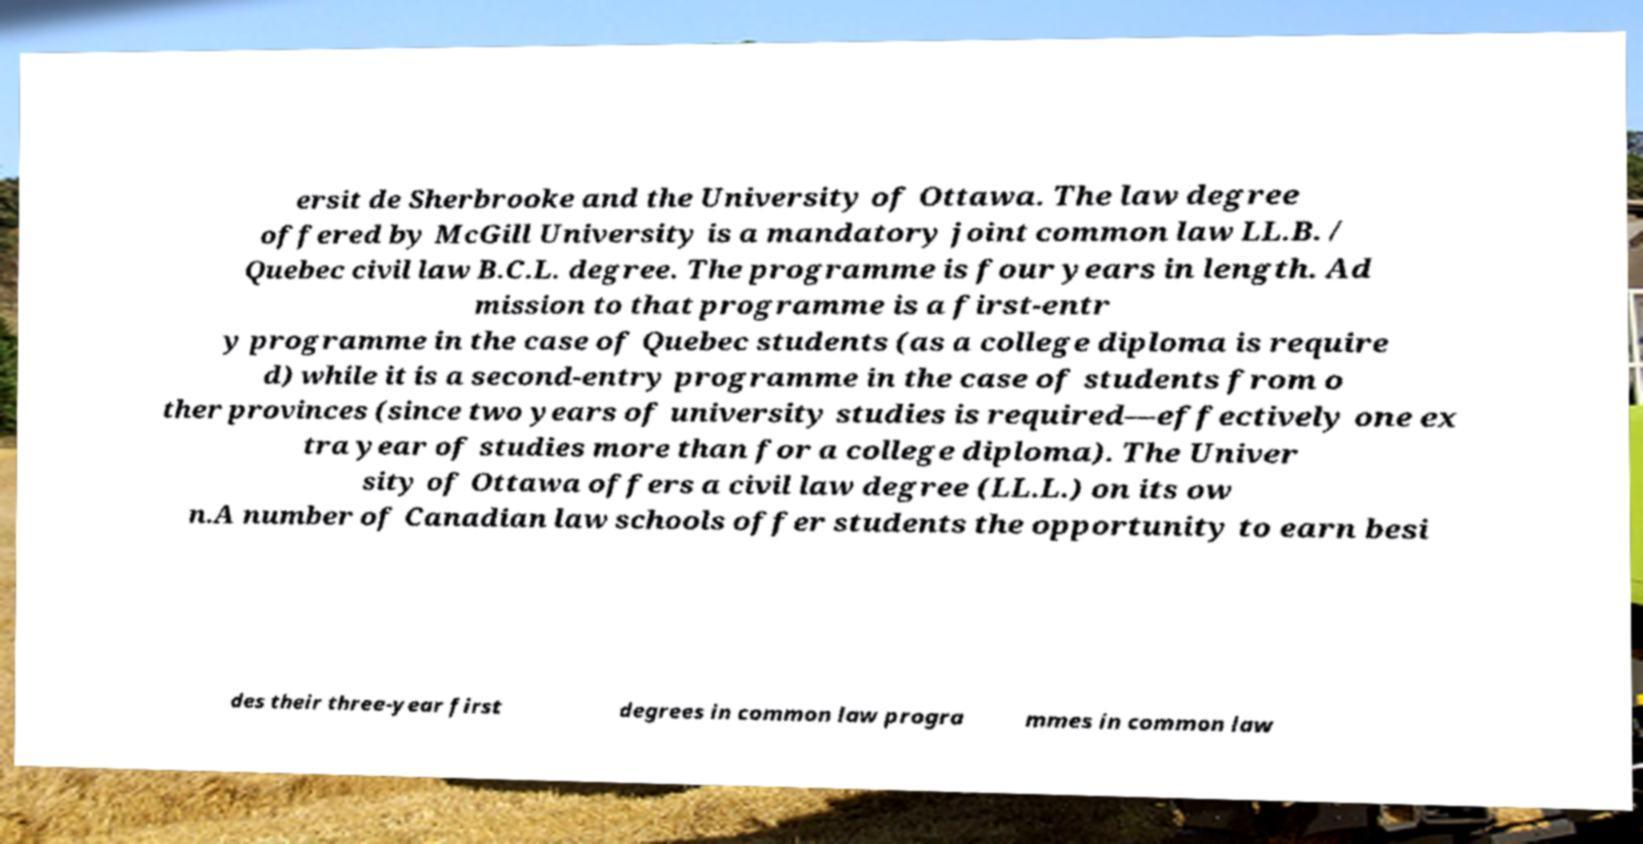I need the written content from this picture converted into text. Can you do that? ersit de Sherbrooke and the University of Ottawa. The law degree offered by McGill University is a mandatory joint common law LL.B. / Quebec civil law B.C.L. degree. The programme is four years in length. Ad mission to that programme is a first-entr y programme in the case of Quebec students (as a college diploma is require d) while it is a second-entry programme in the case of students from o ther provinces (since two years of university studies is required—effectively one ex tra year of studies more than for a college diploma). The Univer sity of Ottawa offers a civil law degree (LL.L.) on its ow n.A number of Canadian law schools offer students the opportunity to earn besi des their three-year first degrees in common law progra mmes in common law 